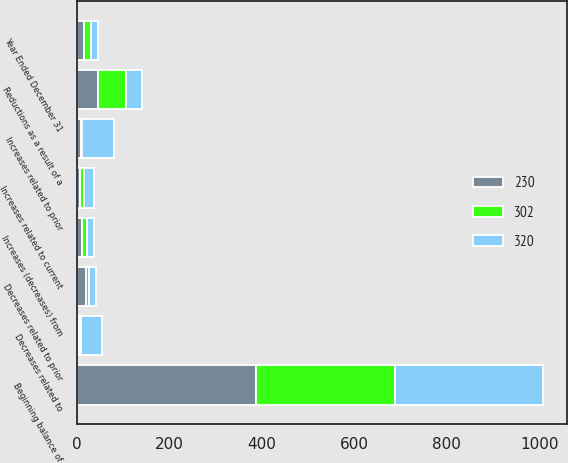<chart> <loc_0><loc_0><loc_500><loc_500><stacked_bar_chart><ecel><fcel>Year Ended December 31<fcel>Beginning balance of<fcel>Increases related to prior<fcel>Decreases related to prior<fcel>Increases related to current<fcel>Decreases related to<fcel>Reductions as a result of a<fcel>Increases (decreases) from<nl><fcel>302<fcel>15<fcel>302<fcel>1<fcel>7<fcel>8<fcel>4<fcel>59<fcel>11<nl><fcel>320<fcel>15<fcel>320<fcel>69<fcel>15<fcel>23<fcel>45<fcel>36<fcel>14<nl><fcel>230<fcel>15<fcel>387<fcel>9<fcel>19<fcel>6<fcel>5<fcel>46<fcel>11<nl></chart> 